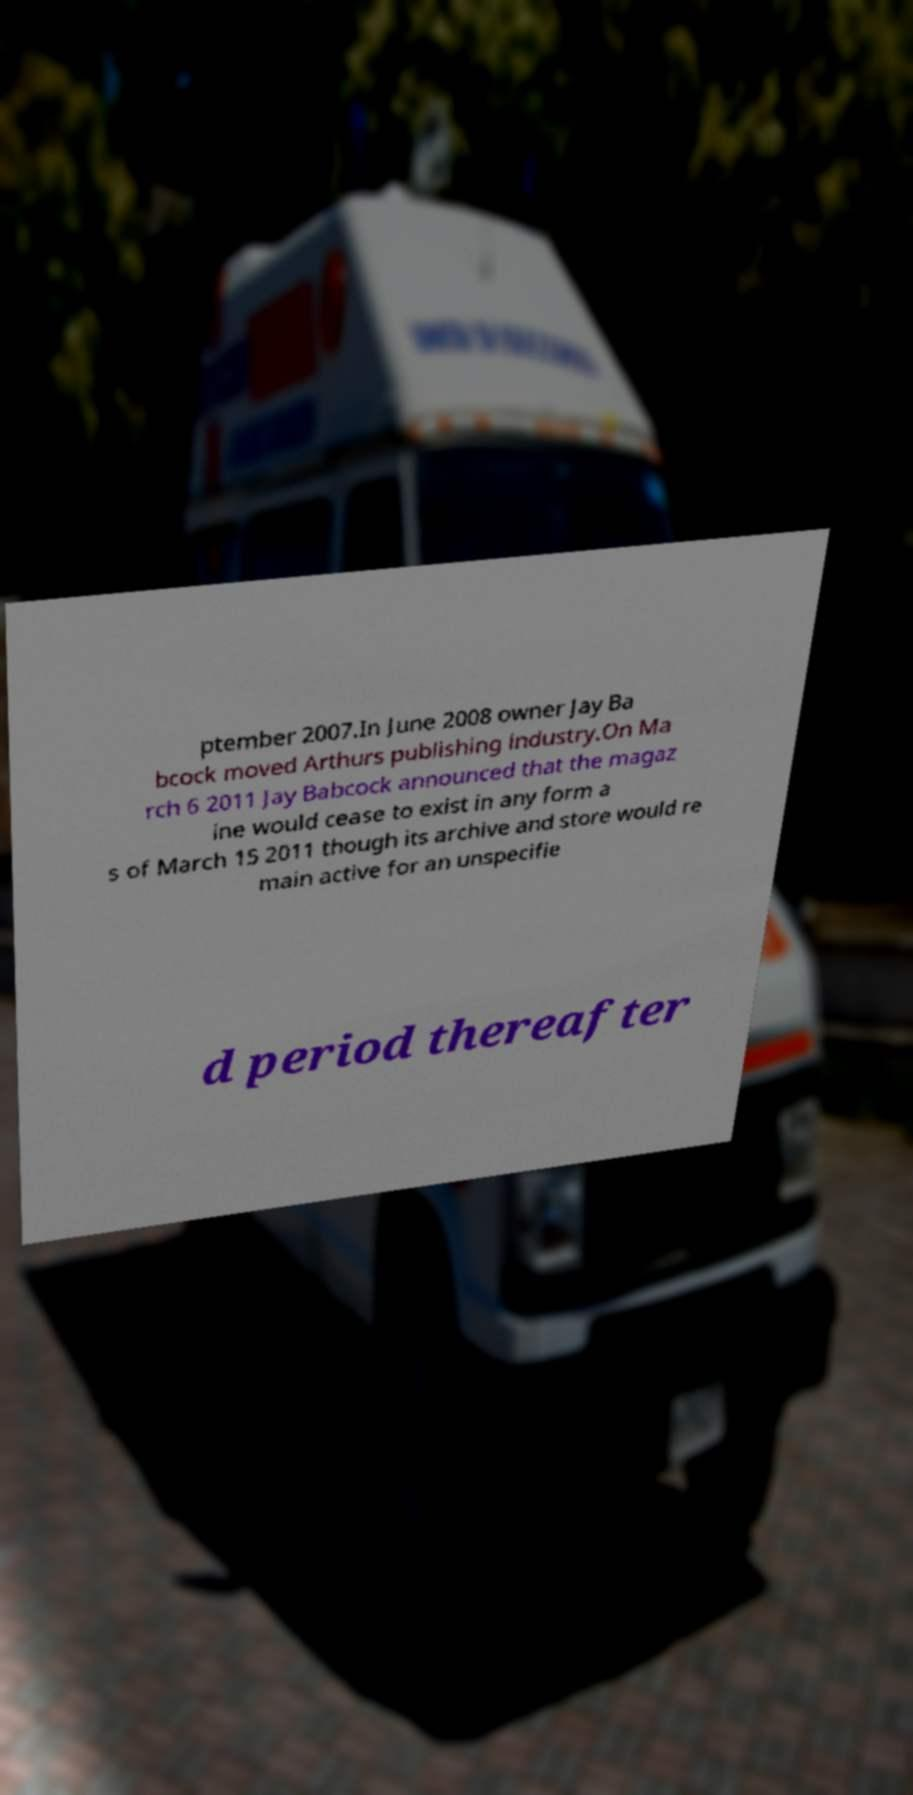Can you read and provide the text displayed in the image?This photo seems to have some interesting text. Can you extract and type it out for me? ptember 2007.In June 2008 owner Jay Ba bcock moved Arthurs publishing industry.On Ma rch 6 2011 Jay Babcock announced that the magaz ine would cease to exist in any form a s of March 15 2011 though its archive and store would re main active for an unspecifie d period thereafter 